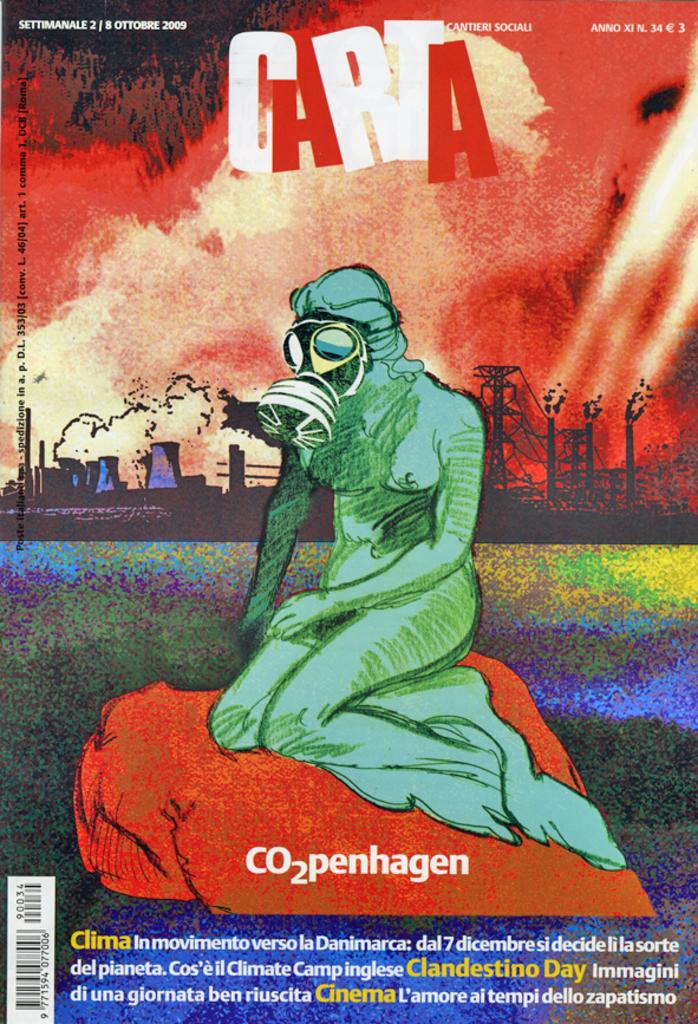What is the title of the book?
Make the answer very short. Carta. 